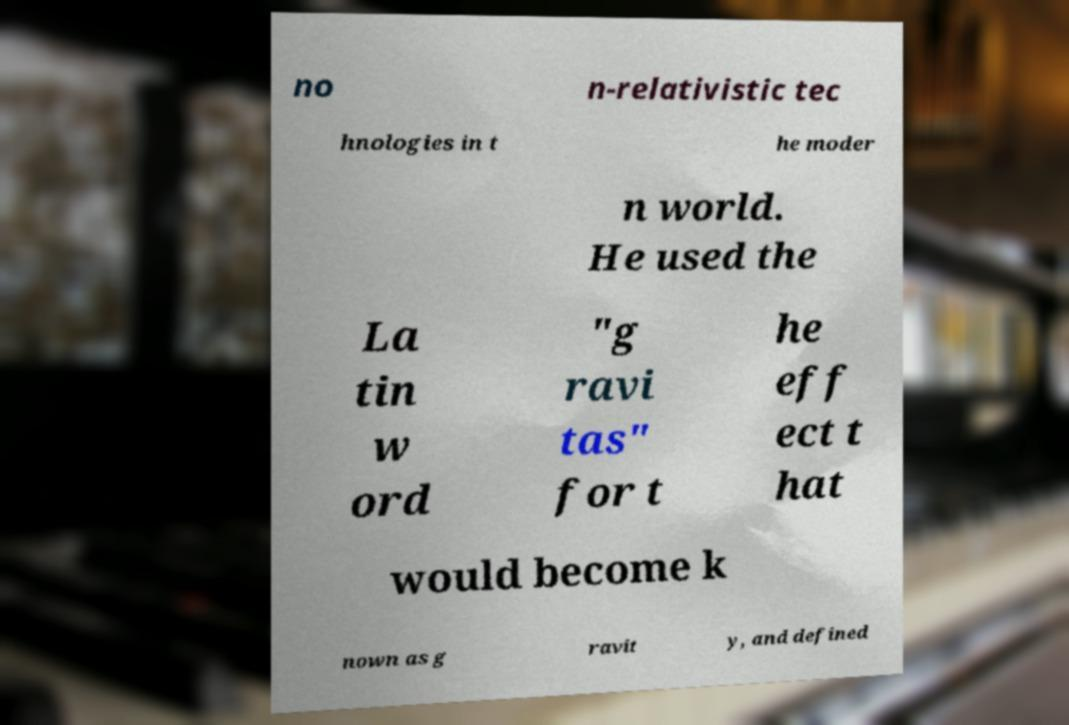There's text embedded in this image that I need extracted. Can you transcribe it verbatim? no n-relativistic tec hnologies in t he moder n world. He used the La tin w ord "g ravi tas" for t he eff ect t hat would become k nown as g ravit y, and defined 